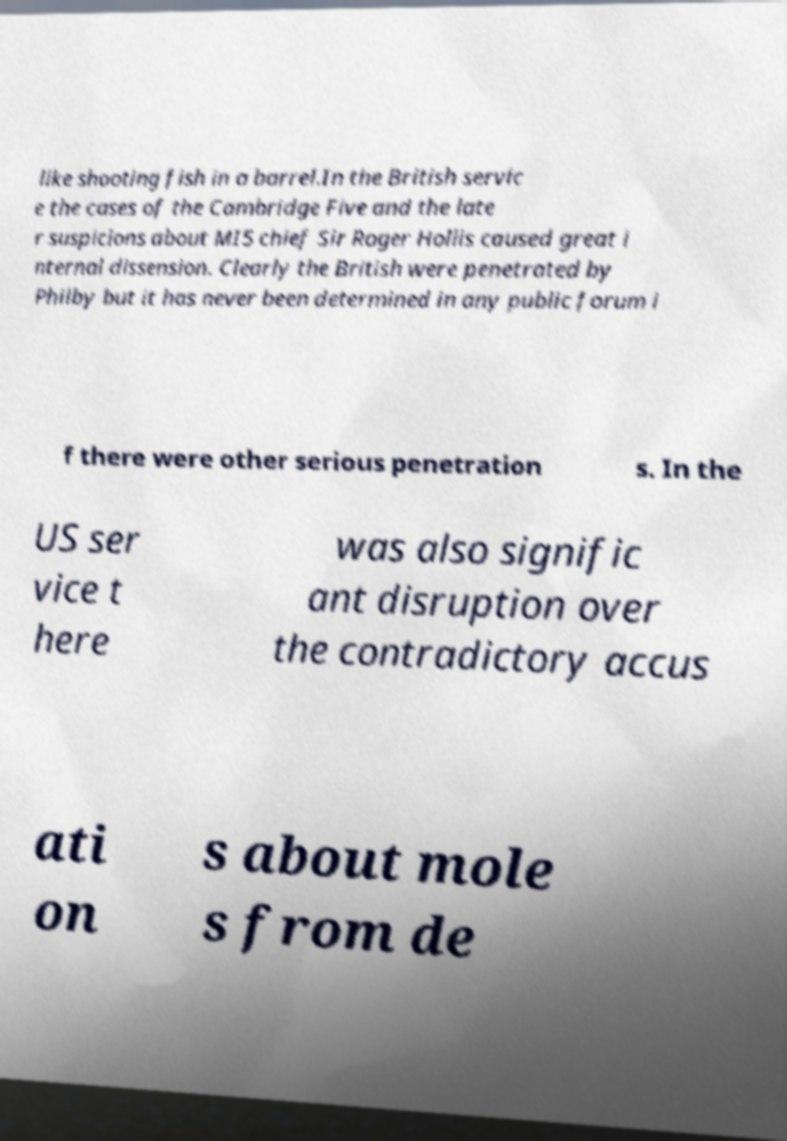Can you read and provide the text displayed in the image?This photo seems to have some interesting text. Can you extract and type it out for me? like shooting fish in a barrel.In the British servic e the cases of the Cambridge Five and the late r suspicions about MI5 chief Sir Roger Hollis caused great i nternal dissension. Clearly the British were penetrated by Philby but it has never been determined in any public forum i f there were other serious penetration s. In the US ser vice t here was also signific ant disruption over the contradictory accus ati on s about mole s from de 